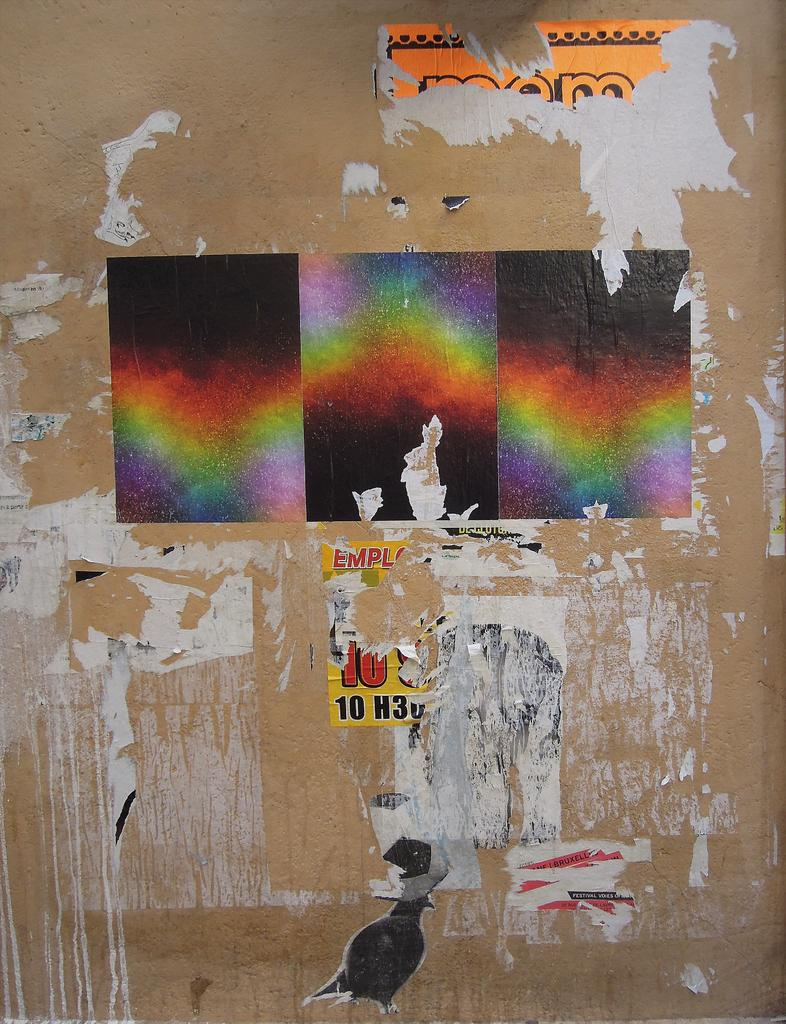What can be seen on the wall in the image? There are posts on the wall in the image. What type of argument can be heard between the posts in the image? There is no argument present in the image; it only shows posts on the wall. What sound does the thunder make in the image? There is no thunder present in the image; it only shows posts on the wall. 